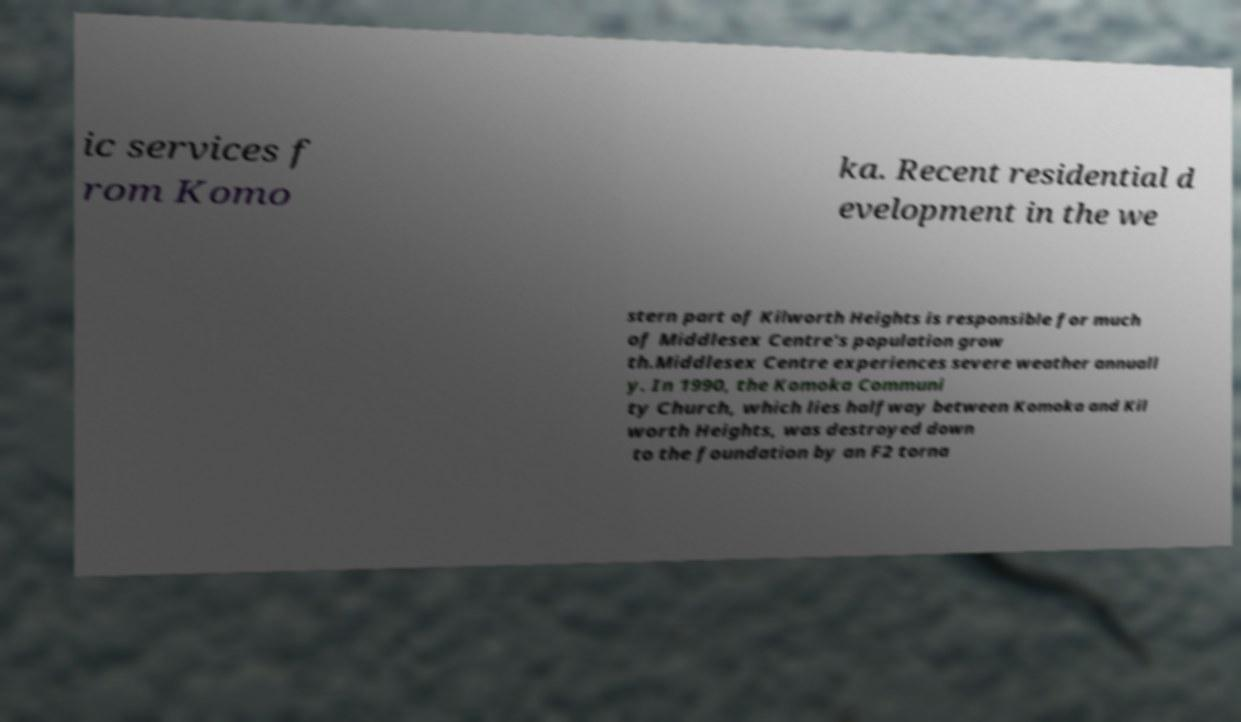Could you assist in decoding the text presented in this image and type it out clearly? ic services f rom Komo ka. Recent residential d evelopment in the we stern part of Kilworth Heights is responsible for much of Middlesex Centre's population grow th.Middlesex Centre experiences severe weather annuall y. In 1990, the Komoka Communi ty Church, which lies halfway between Komoka and Kil worth Heights, was destroyed down to the foundation by an F2 torna 